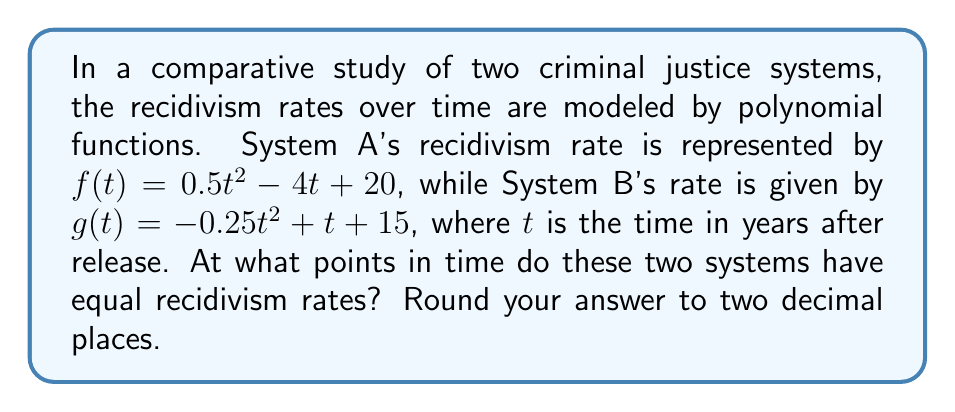What is the answer to this math problem? To find the points where the two systems have equal recidivism rates, we need to find the intersection points of the two polynomial functions. This involves solving the equation:

$$f(t) = g(t)$$

Substituting the given functions:

$$0.5t^2 - 4t + 20 = -0.25t^2 + t + 15$$

Rearranging the equation to standard form:

$$0.5t^2 - 4t + 20 + 0.25t^2 - t - 15 = 0$$
$$0.75t^2 - 5t + 5 = 0$$

This is a quadratic equation in the form $at^2 + bt + c = 0$, where:
$a = 0.75$
$b = -5$
$c = 5$

We can solve this using the quadratic formula: $t = \frac{-b \pm \sqrt{b^2 - 4ac}}{2a}$

Substituting the values:

$$t = \frac{5 \pm \sqrt{(-5)^2 - 4(0.75)(5)}}{2(0.75)}$$
$$t = \frac{5 \pm \sqrt{25 - 15}}{1.5}$$
$$t = \frac{5 \pm \sqrt{10}}{1.5}$$

Calculating the two solutions:

$$t_1 = \frac{5 + \sqrt{10}}{1.5} \approx 5.44$$
$$t_2 = \frac{5 - \sqrt{10}}{1.5} \approx 1.22$$

Therefore, the two systems have equal recidivism rates at approximately 1.22 years and 5.44 years after release.
Answer: The two criminal justice systems have equal recidivism rates at t ≈ 1.22 years and t ≈ 5.44 years after release. 